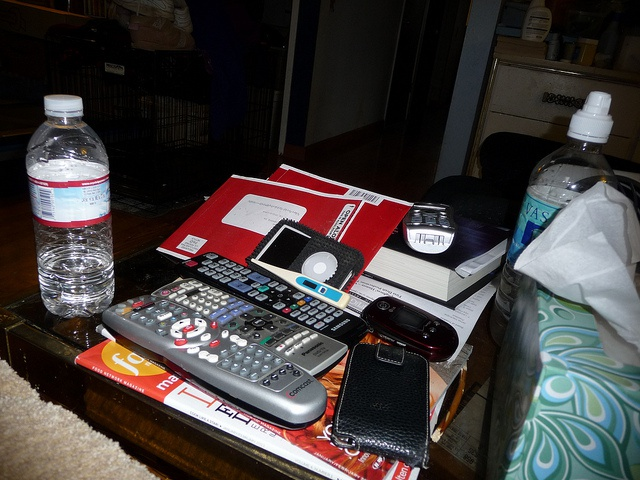Describe the objects in this image and their specific colors. I can see bottle in black, gray, lightgray, and darkgray tones, remote in black, gray, darkgray, and white tones, bottle in black, gray, darkgray, and teal tones, book in black, lightgray, darkgray, and gray tones, and remote in black, gray, darkgray, and lightgray tones in this image. 